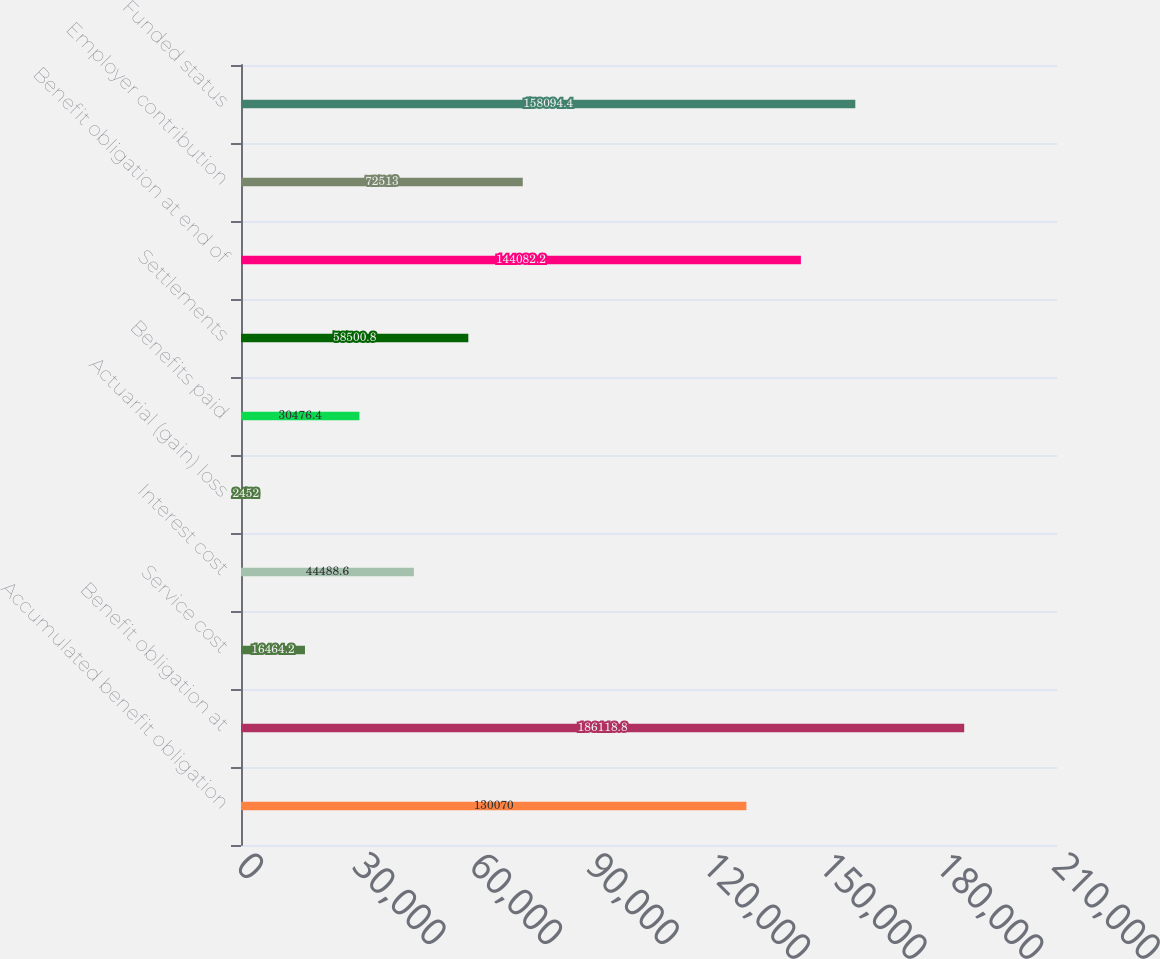<chart> <loc_0><loc_0><loc_500><loc_500><bar_chart><fcel>Accumulated benefit obligation<fcel>Benefit obligation at<fcel>Service cost<fcel>Interest cost<fcel>Actuarial (gain) loss<fcel>Benefits paid<fcel>Settlements<fcel>Benefit obligation at end of<fcel>Employer contribution<fcel>Funded status<nl><fcel>130070<fcel>186119<fcel>16464.2<fcel>44488.6<fcel>2452<fcel>30476.4<fcel>58500.8<fcel>144082<fcel>72513<fcel>158094<nl></chart> 